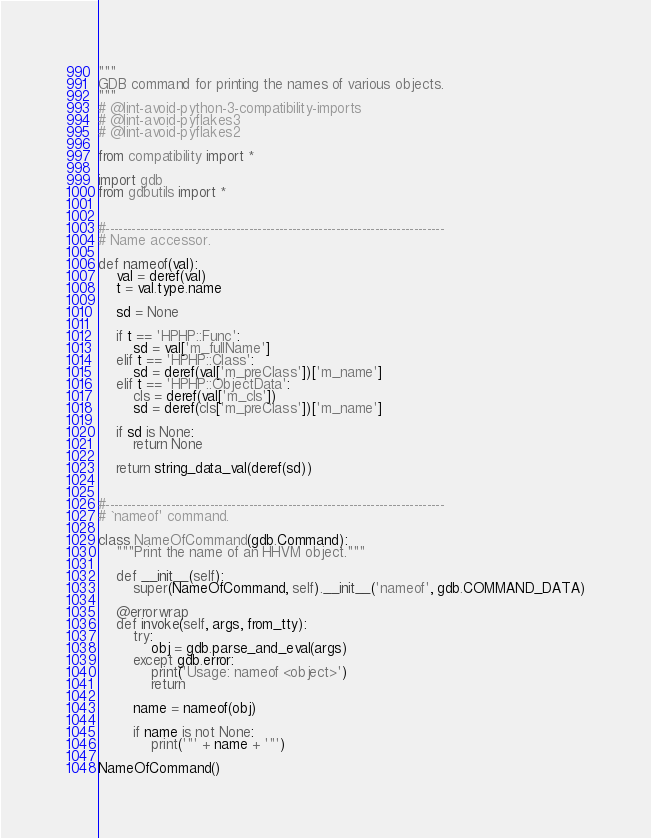Convert code to text. <code><loc_0><loc_0><loc_500><loc_500><_Python_>"""
GDB command for printing the names of various objects.
"""
# @lint-avoid-python-3-compatibility-imports
# @lint-avoid-pyflakes3
# @lint-avoid-pyflakes2

from compatibility import *

import gdb
from gdbutils import *


#------------------------------------------------------------------------------
# Name accessor.

def nameof(val):
    val = deref(val)
    t = val.type.name

    sd = None

    if t == 'HPHP::Func':
        sd = val['m_fullName']
    elif t == 'HPHP::Class':
        sd = deref(val['m_preClass'])['m_name']
    elif t == 'HPHP::ObjectData':
        cls = deref(val['m_cls'])
        sd = deref(cls['m_preClass'])['m_name']

    if sd is None:
        return None

    return string_data_val(deref(sd))


#------------------------------------------------------------------------------
# `nameof' command.

class NameOfCommand(gdb.Command):
    """Print the name of an HHVM object."""

    def __init__(self):
        super(NameOfCommand, self).__init__('nameof', gdb.COMMAND_DATA)

    @errorwrap
    def invoke(self, args, from_tty):
        try:
            obj = gdb.parse_and_eval(args)
        except gdb.error:
            print('Usage: nameof <object>')
            return

        name = nameof(obj)

        if name is not None:
            print('"' + name + '"')

NameOfCommand()
</code> 